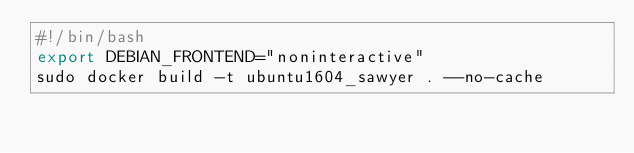<code> <loc_0><loc_0><loc_500><loc_500><_Bash_>#!/bin/bash
export DEBIAN_FRONTEND="noninteractive"
sudo docker build -t ubuntu1604_sawyer . --no-cache
</code> 